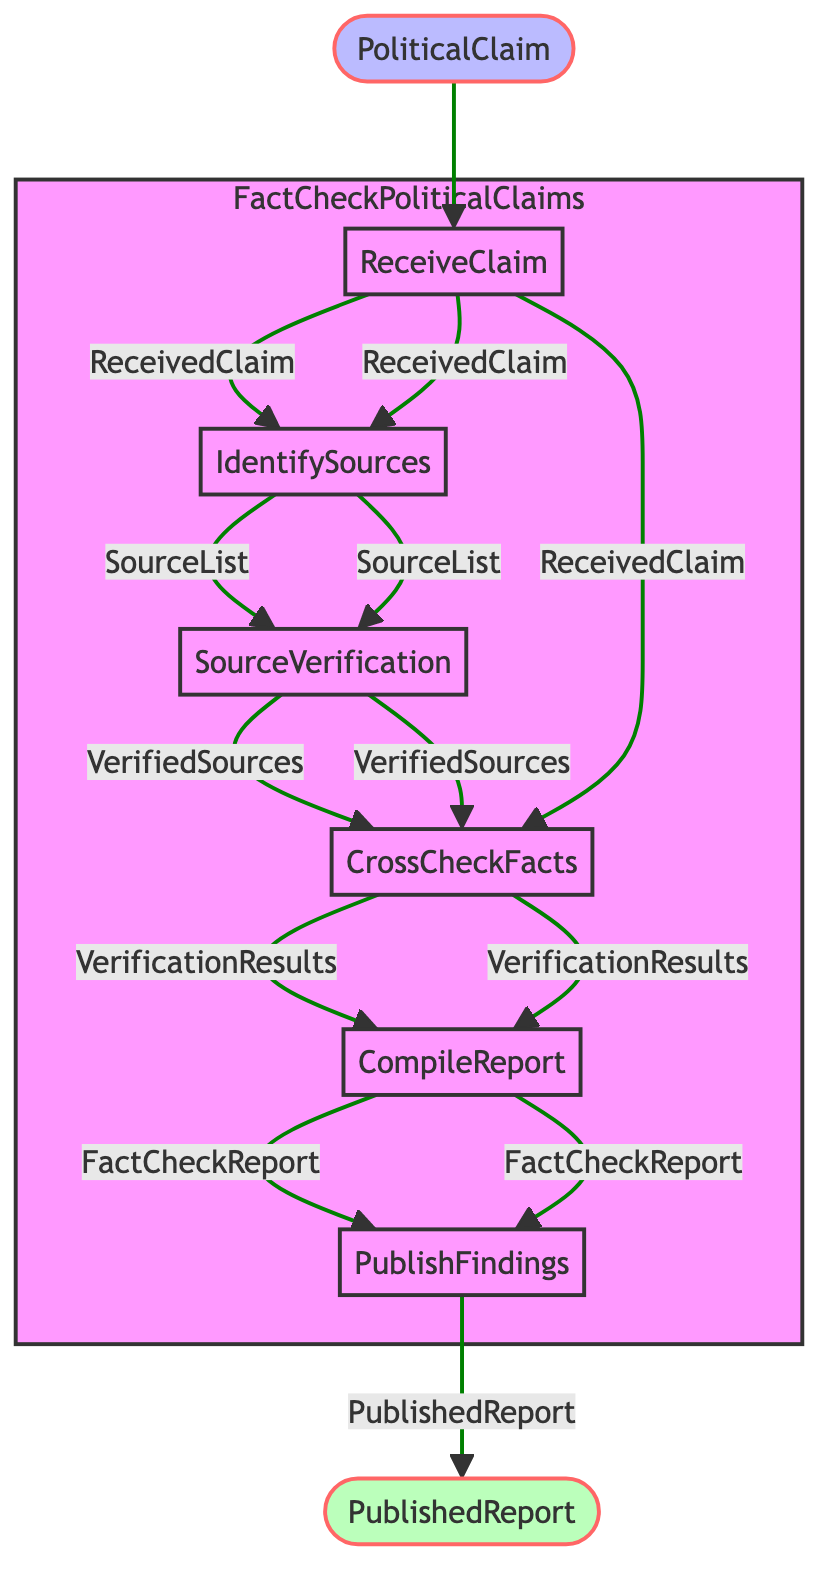What is the first step in the fact-checking process? The first step is "ReceiveClaim," where the political claim is received from a source.
Answer: ReceiveClaim How many steps are there in the process? The diagram has a total of six steps labeled from "ReceiveClaim" to "PublishFindings."
Answer: Six What is the output of the "CompileReport" step? The output of the "CompileReport" step is a document called "FactCheckReport," which summarizes the findings with supporting evidence.
Answer: FactCheckReport Which step follows "CrossCheckFacts"? After "CrossCheckFacts," the next step in the process is "CompileReport."
Answer: CompileReport What inputs are needed for "SourceVerification"? The step "SourceVerification" requires the input "SourceList," which contains the identified potential sources to cross-check the claim.
Answer: SourceList Which steps produce outputs that lead directly to the publication of the findings? The steps "CompileReport" and "CrossCheckFacts" produce outputs that are eventually used for publishing the findings; "CompileReport" leads to "FactCheckReport," which is followed by "PublishFindings."
Answer: CompileReport, CrossCheckFacts In what step do you verify the credibility of sources? The verification of the credibility of sources occurs in the "SourceVerification" step, where the past reliability and potential biases of the sources are assessed.
Answer: SourceVerification What is the relationship between "ReceiveClaim" and "CrossCheckFacts"? "ReceiveClaim" provides an output called "ReceivedClaim," which is then used as an input in the "CrossCheckFacts" step along with "VerifiedSources."
Answer: "ReceiveClaim" provides "ReceivedClaim" to "CrossCheckFacts" What is the final output of the function? The final output of the function is "PublishedReport," which is the end result of publishing the fact-checking report.
Answer: PublishedReport 